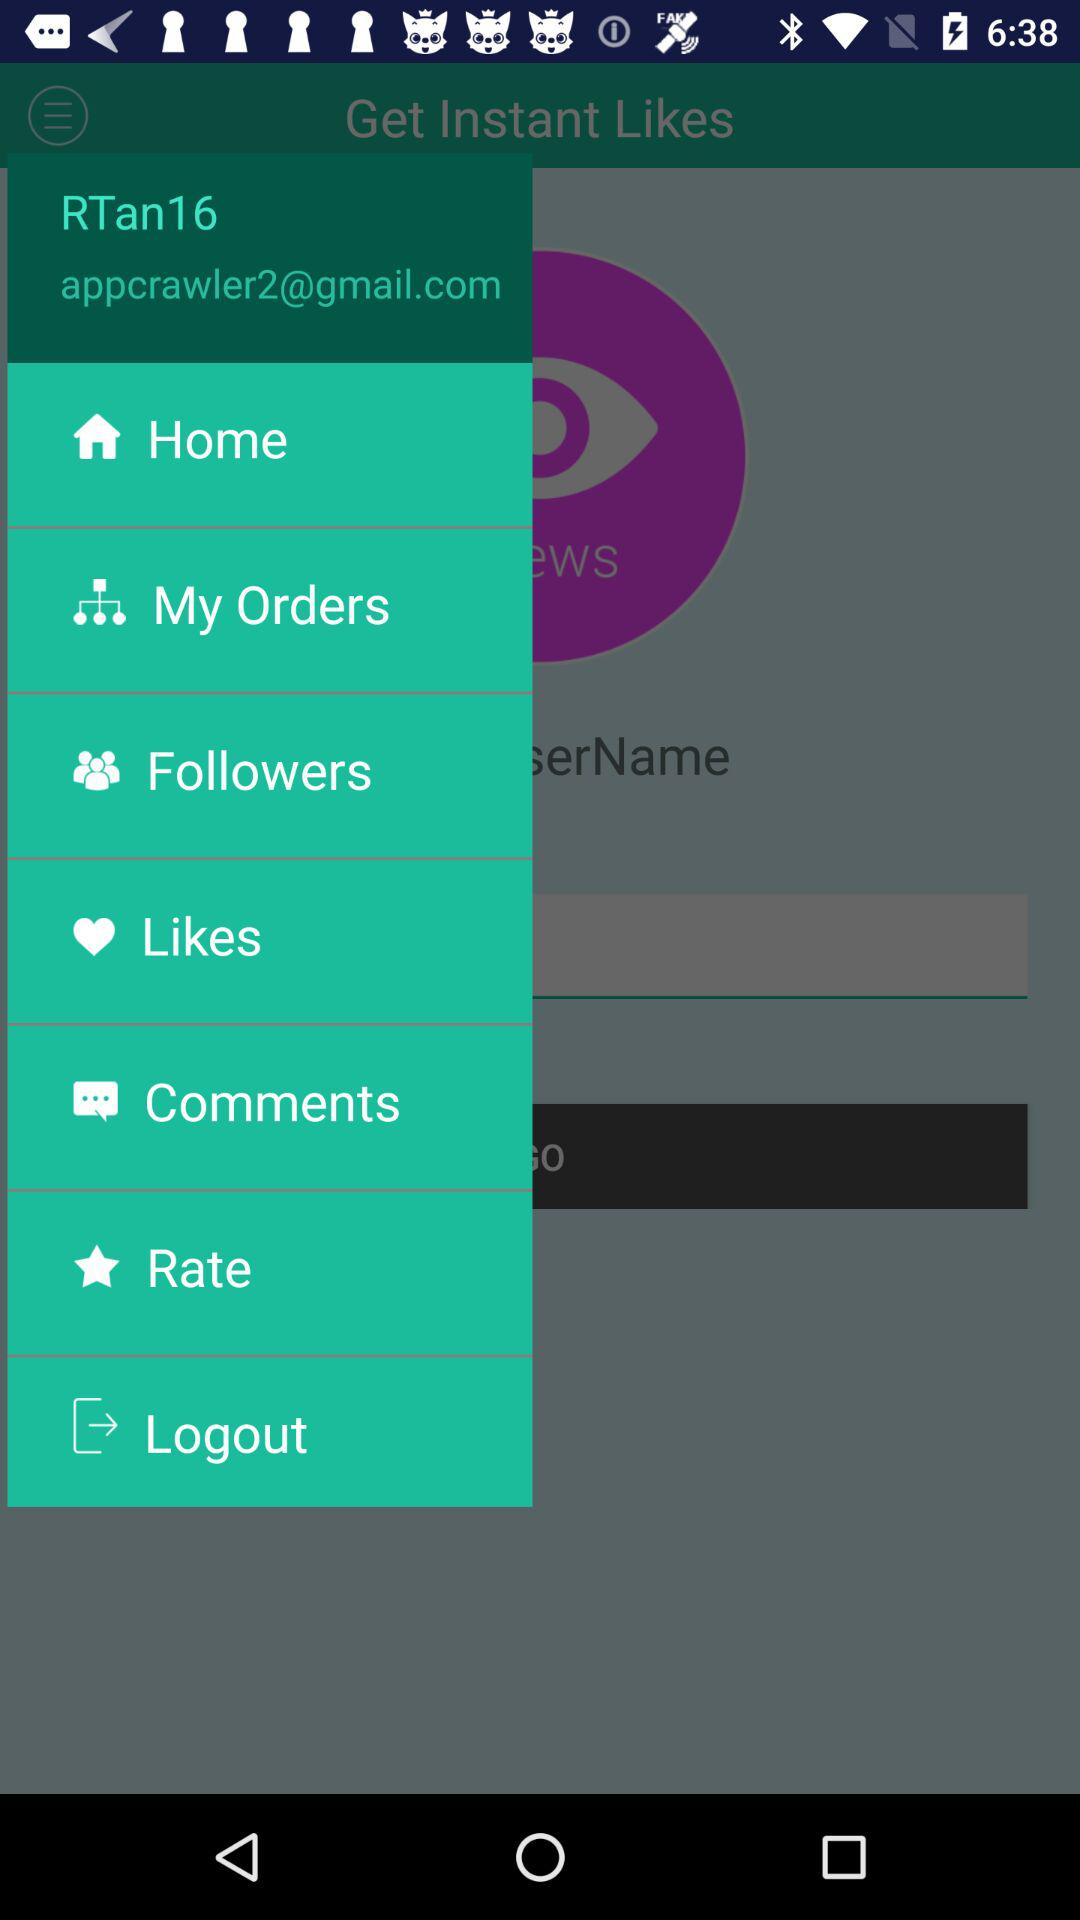What is the user name? The user name is "RTan16". 